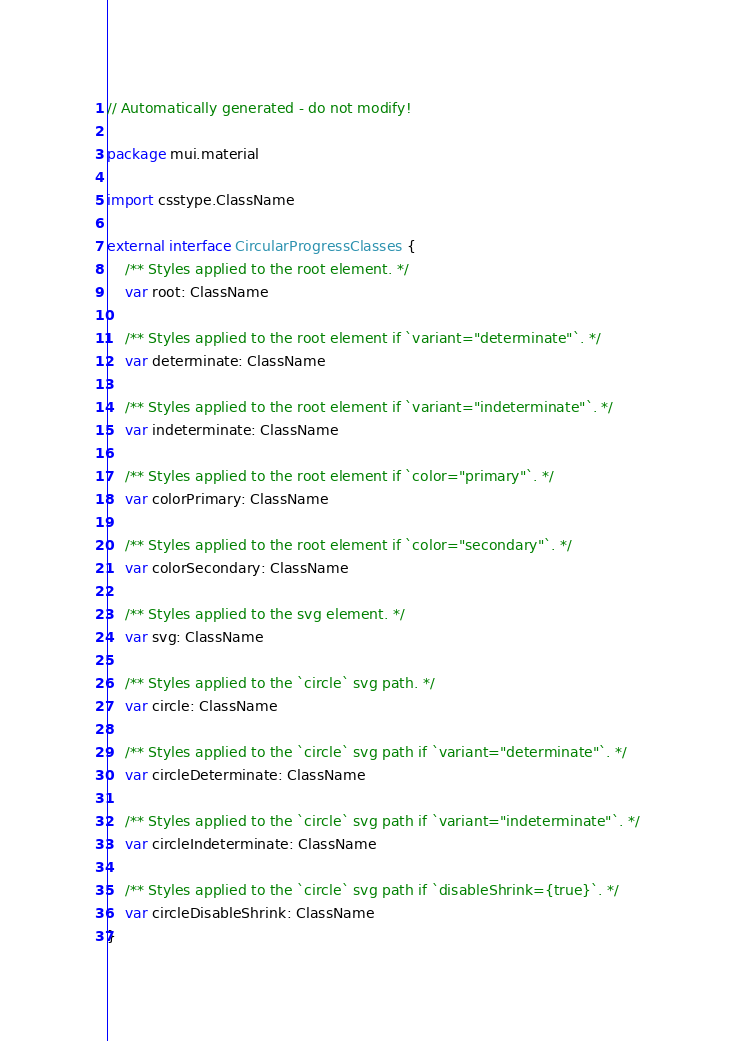<code> <loc_0><loc_0><loc_500><loc_500><_Kotlin_>// Automatically generated - do not modify!

package mui.material

import csstype.ClassName

external interface CircularProgressClasses {
    /** Styles applied to the root element. */
    var root: ClassName

    /** Styles applied to the root element if `variant="determinate"`. */
    var determinate: ClassName

    /** Styles applied to the root element if `variant="indeterminate"`. */
    var indeterminate: ClassName

    /** Styles applied to the root element if `color="primary"`. */
    var colorPrimary: ClassName

    /** Styles applied to the root element if `color="secondary"`. */
    var colorSecondary: ClassName

    /** Styles applied to the svg element. */
    var svg: ClassName

    /** Styles applied to the `circle` svg path. */
    var circle: ClassName

    /** Styles applied to the `circle` svg path if `variant="determinate"`. */
    var circleDeterminate: ClassName

    /** Styles applied to the `circle` svg path if `variant="indeterminate"`. */
    var circleIndeterminate: ClassName

    /** Styles applied to the `circle` svg path if `disableShrink={true}`. */
    var circleDisableShrink: ClassName
}
</code> 